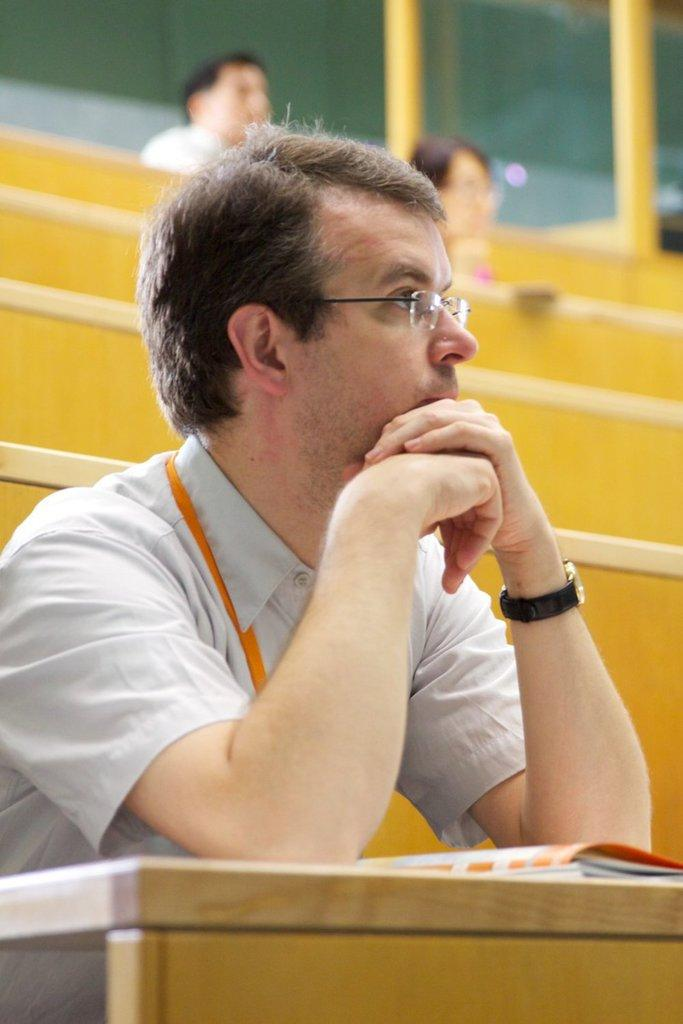What is the person in the image wearing on their face? The person is wearing goggles. What accessory is the person wearing on their wrist? The person is wearing a watch. Where is the person sitting in the image? The person is sitting on a bench. What object is in front of the person? There is a book in front of the person. How many people are visible behind the person? There are two people behind the person. What architectural feature can be seen in the image? There are pillars visible in the image. What type of balloon is the person holding in the image? There is no balloon present in the image. How does the person's laughter sound in the image? The image does not depict any sound or laughter. 